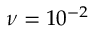<formula> <loc_0><loc_0><loc_500><loc_500>\nu = 1 0 ^ { - 2 }</formula> 